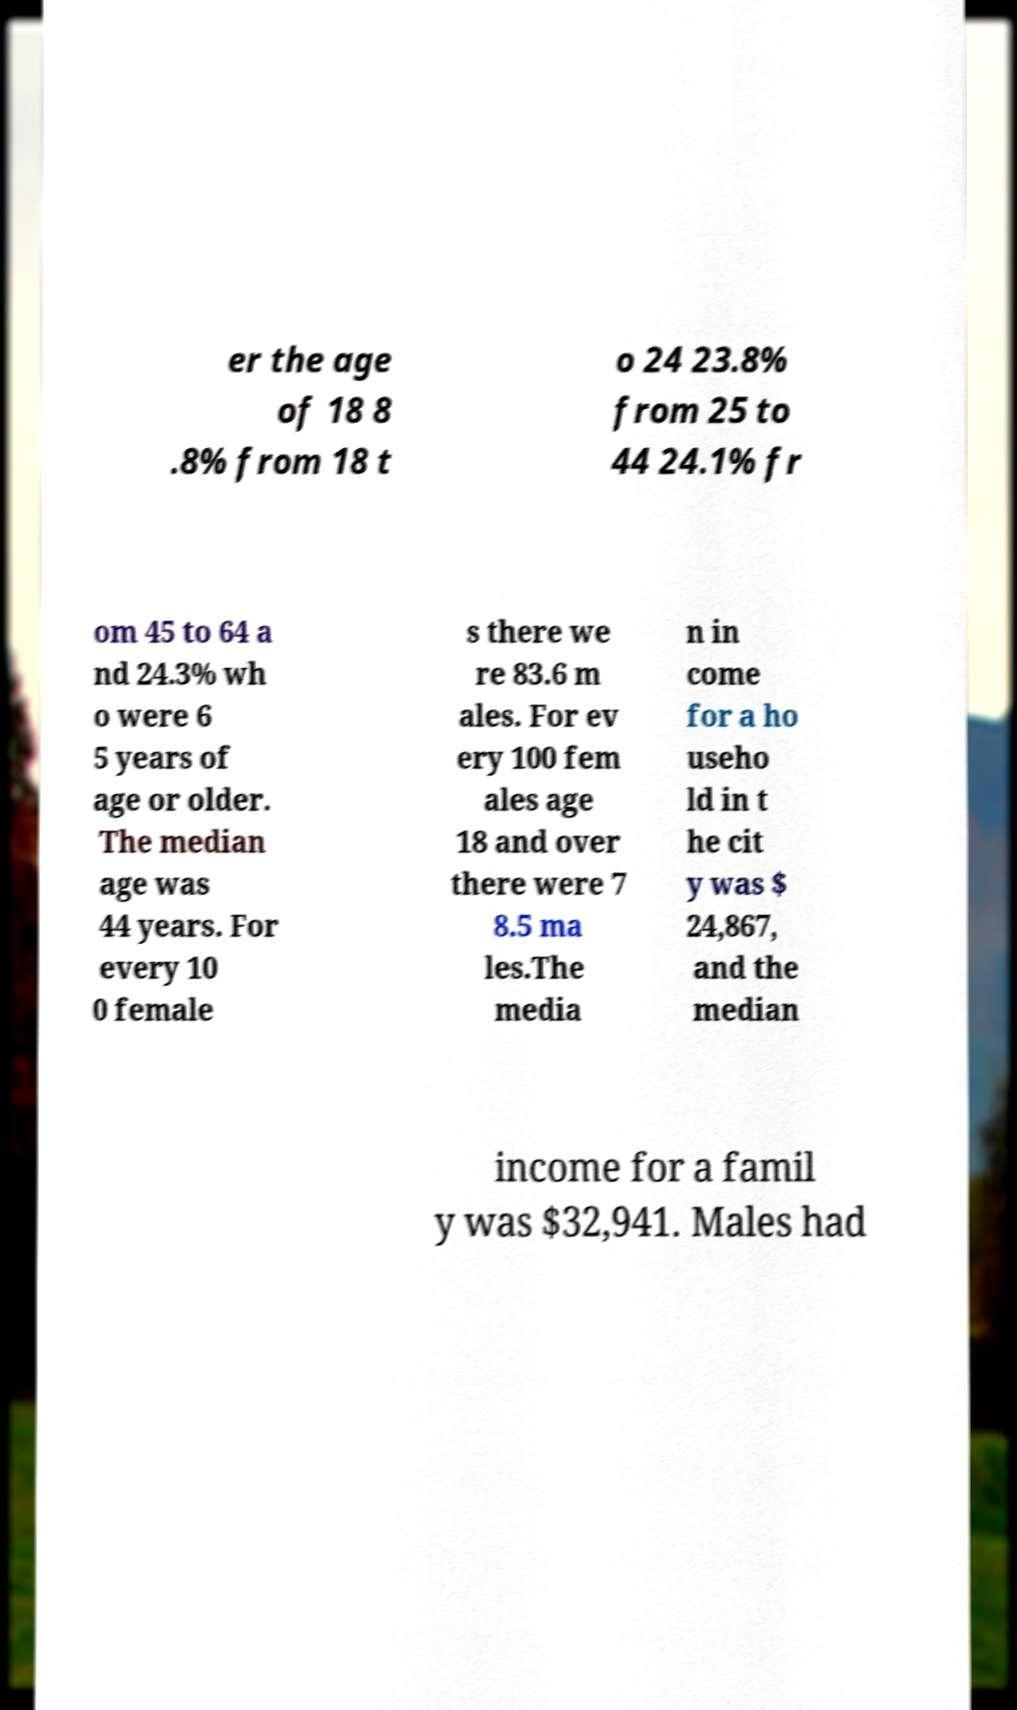Can you accurately transcribe the text from the provided image for me? er the age of 18 8 .8% from 18 t o 24 23.8% from 25 to 44 24.1% fr om 45 to 64 a nd 24.3% wh o were 6 5 years of age or older. The median age was 44 years. For every 10 0 female s there we re 83.6 m ales. For ev ery 100 fem ales age 18 and over there were 7 8.5 ma les.The media n in come for a ho useho ld in t he cit y was $ 24,867, and the median income for a famil y was $32,941. Males had 